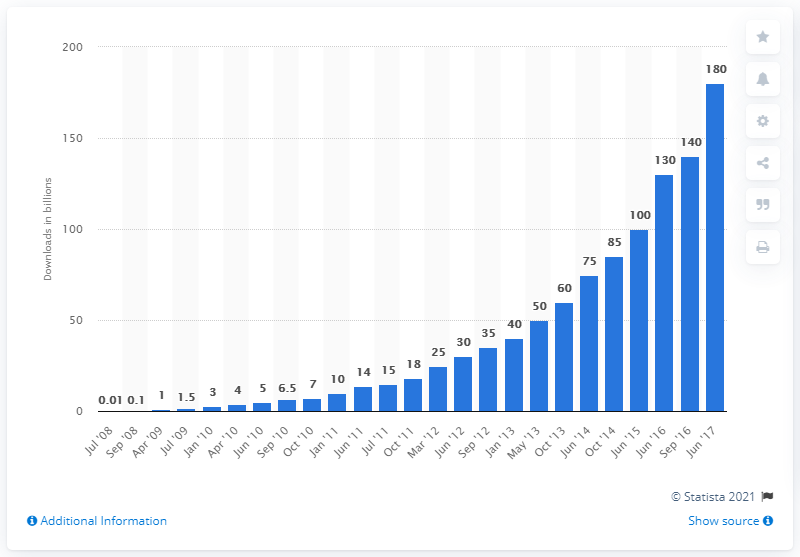List a handful of essential elements in this visual. As of June 2017, a total of 180 apps had been downloaded from Apple's App Store. 